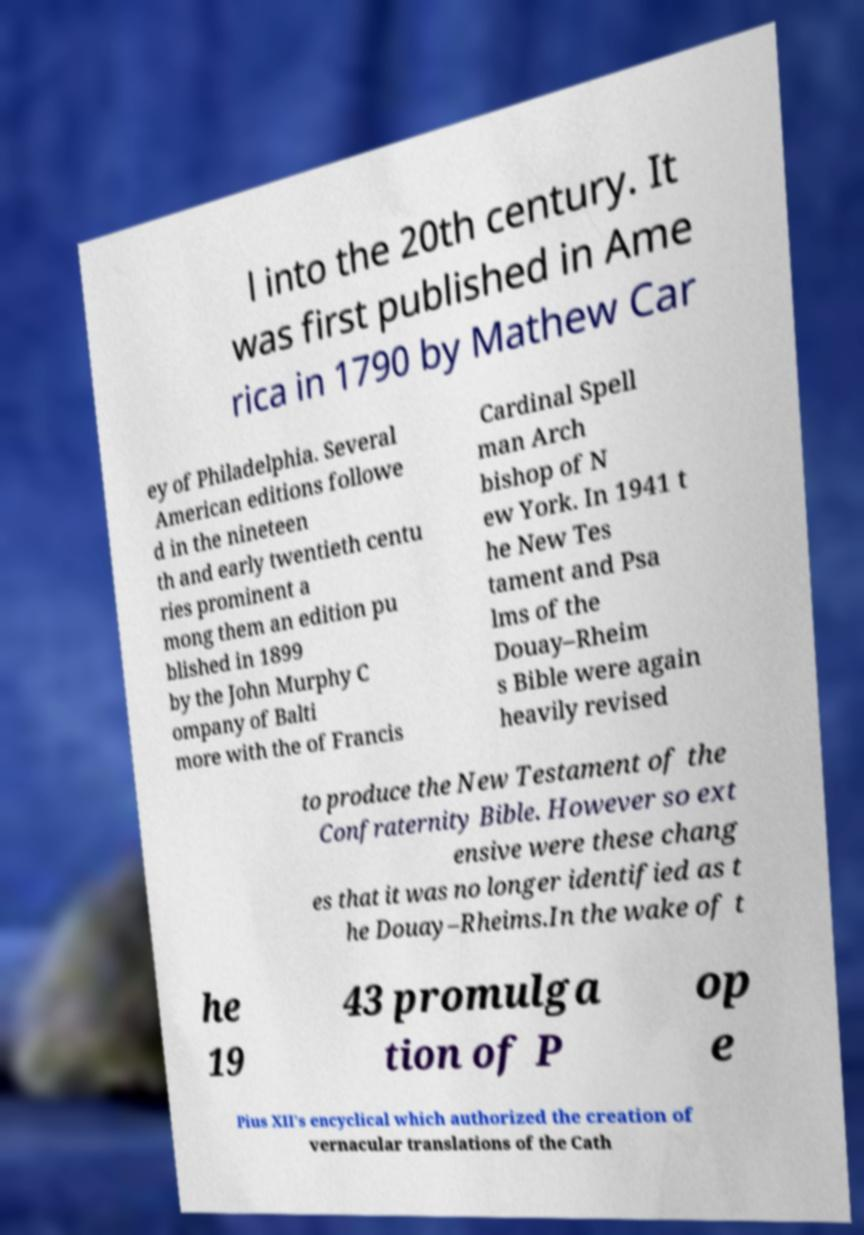Can you read and provide the text displayed in the image?This photo seems to have some interesting text. Can you extract and type it out for me? l into the 20th century. It was first published in Ame rica in 1790 by Mathew Car ey of Philadelphia. Several American editions followe d in the nineteen th and early twentieth centu ries prominent a mong them an edition pu blished in 1899 by the John Murphy C ompany of Balti more with the of Francis Cardinal Spell man Arch bishop of N ew York. In 1941 t he New Tes tament and Psa lms of the Douay–Rheim s Bible were again heavily revised to produce the New Testament of the Confraternity Bible. However so ext ensive were these chang es that it was no longer identified as t he Douay–Rheims.In the wake of t he 19 43 promulga tion of P op e Pius XII's encyclical which authorized the creation of vernacular translations of the Cath 